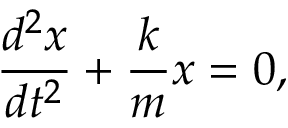<formula> <loc_0><loc_0><loc_500><loc_500>{ \frac { d ^ { 2 } x } { d t ^ { 2 } } } + { \frac { k } { m } } x = 0 ,</formula> 